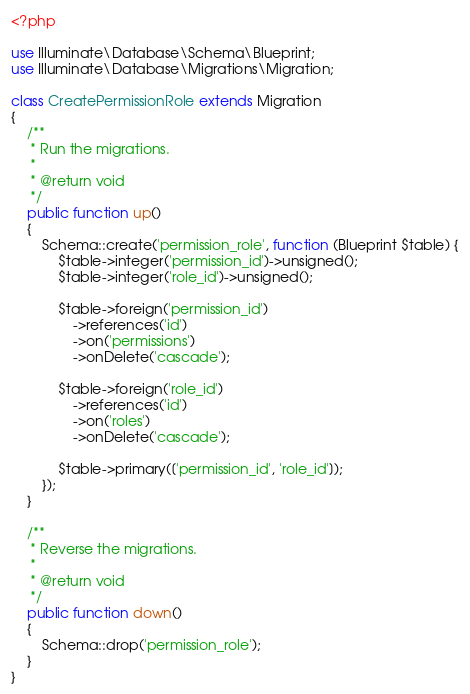Convert code to text. <code><loc_0><loc_0><loc_500><loc_500><_PHP_><?php

use Illuminate\Database\Schema\Blueprint;
use Illuminate\Database\Migrations\Migration;

class CreatePermissionRole extends Migration
{
    /**
     * Run the migrations.
     *
     * @return void
     */
    public function up()
    {
        Schema::create('permission_role', function (Blueprint $table) {
            $table->integer('permission_id')->unsigned();
            $table->integer('role_id')->unsigned();

            $table->foreign('permission_id')
                ->references('id')
                ->on('permissions')
                ->onDelete('cascade');

            $table->foreign('role_id')
                ->references('id')
                ->on('roles')
                ->onDelete('cascade');

            $table->primary(['permission_id', 'role_id']);
        });
    }

    /**
     * Reverse the migrations.
     *
     * @return void
     */
    public function down()
    {
        Schema::drop('permission_role');
    }
}
</code> 